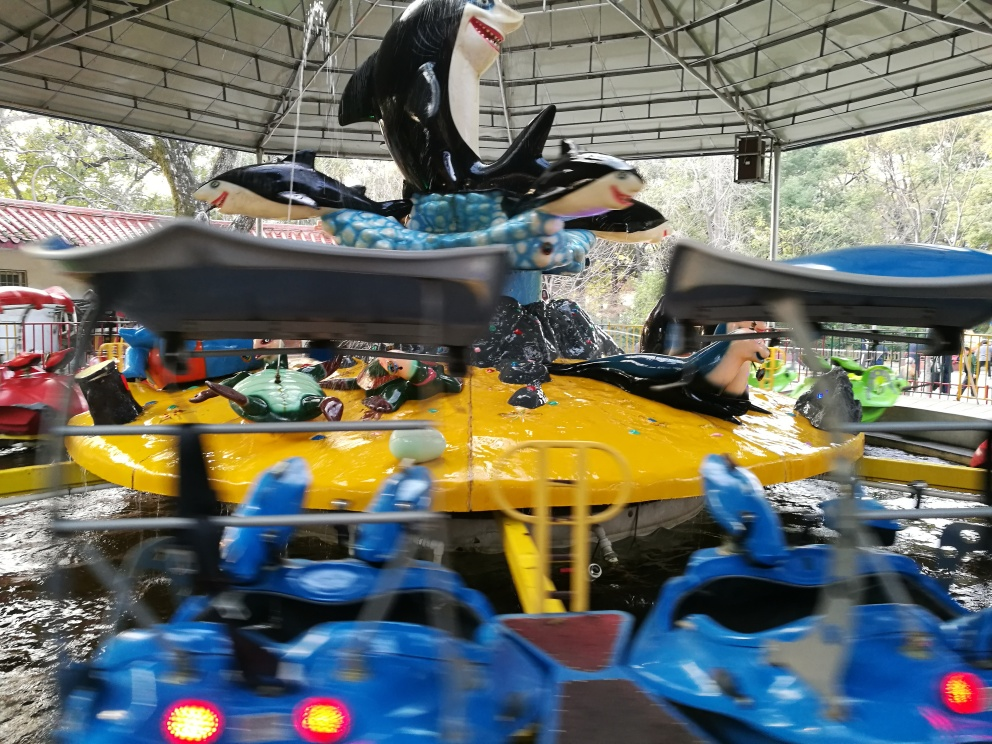What is the color quality of the image?
A. Bright
B. Vivid
C. Dull
D. Faded
Answer with the option's letter from the given choices directly. The color quality of the image can be described as vivid (option B). Despite the motion blur, the colors are rich and intense, especially the bright yellow of the carousel and the varying shades of blue. These elements contribute to a lively and dynamic scene. 